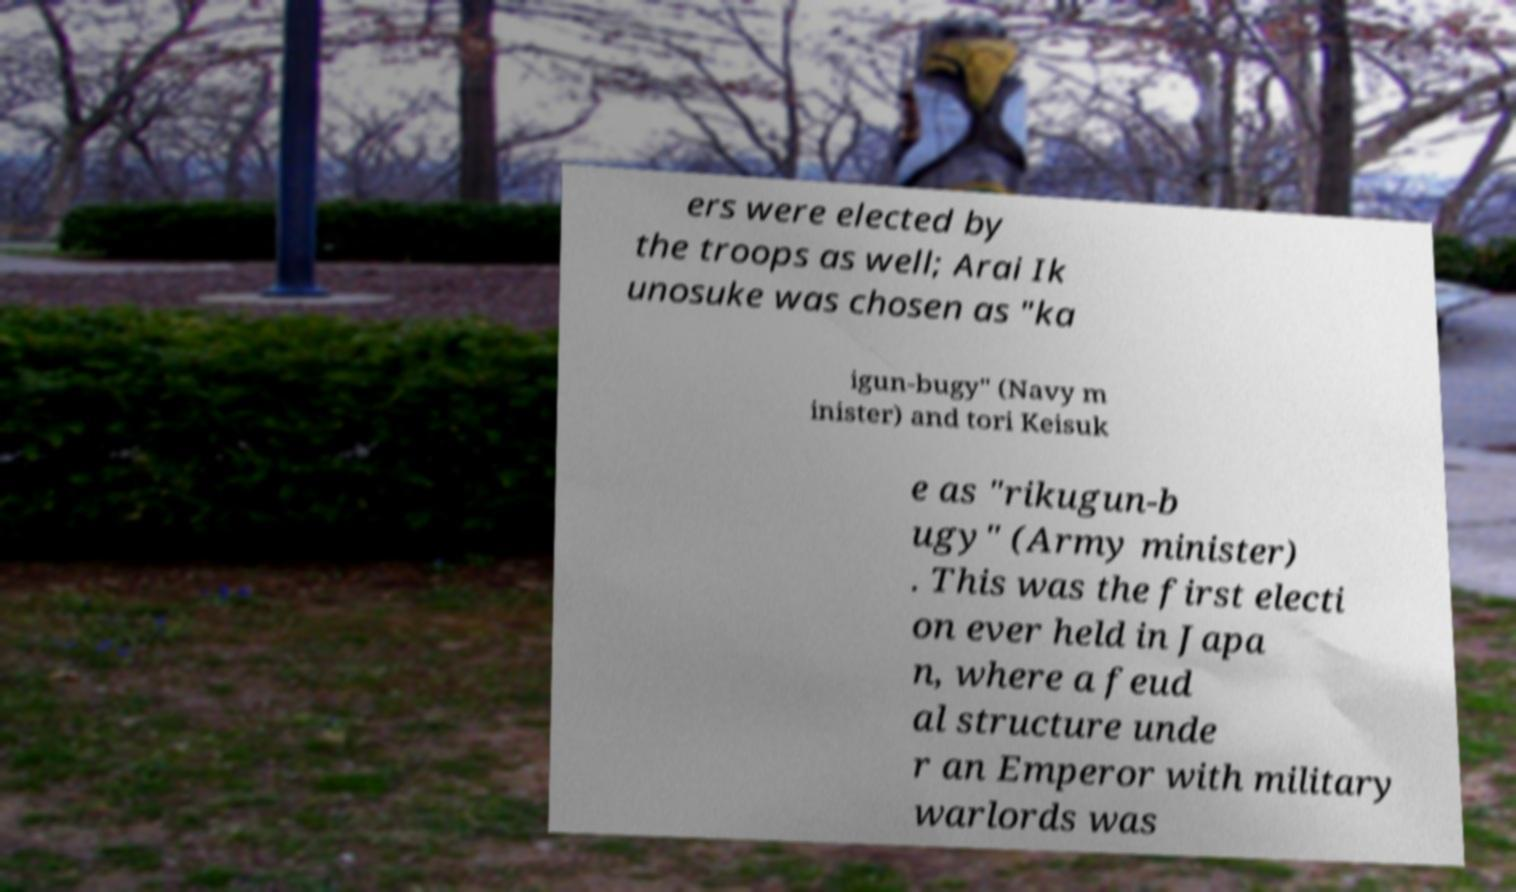What messages or text are displayed in this image? I need them in a readable, typed format. ers were elected by the troops as well; Arai Ik unosuke was chosen as "ka igun-bugy" (Navy m inister) and tori Keisuk e as "rikugun-b ugy" (Army minister) . This was the first electi on ever held in Japa n, where a feud al structure unde r an Emperor with military warlords was 